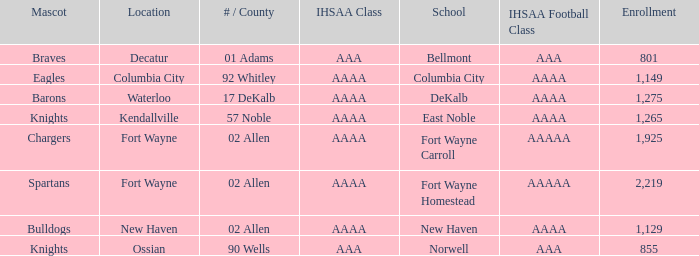What school has a mascot of the spartans with an AAAA IHSAA class and more than 1,275 enrolled? Fort Wayne Homestead. 